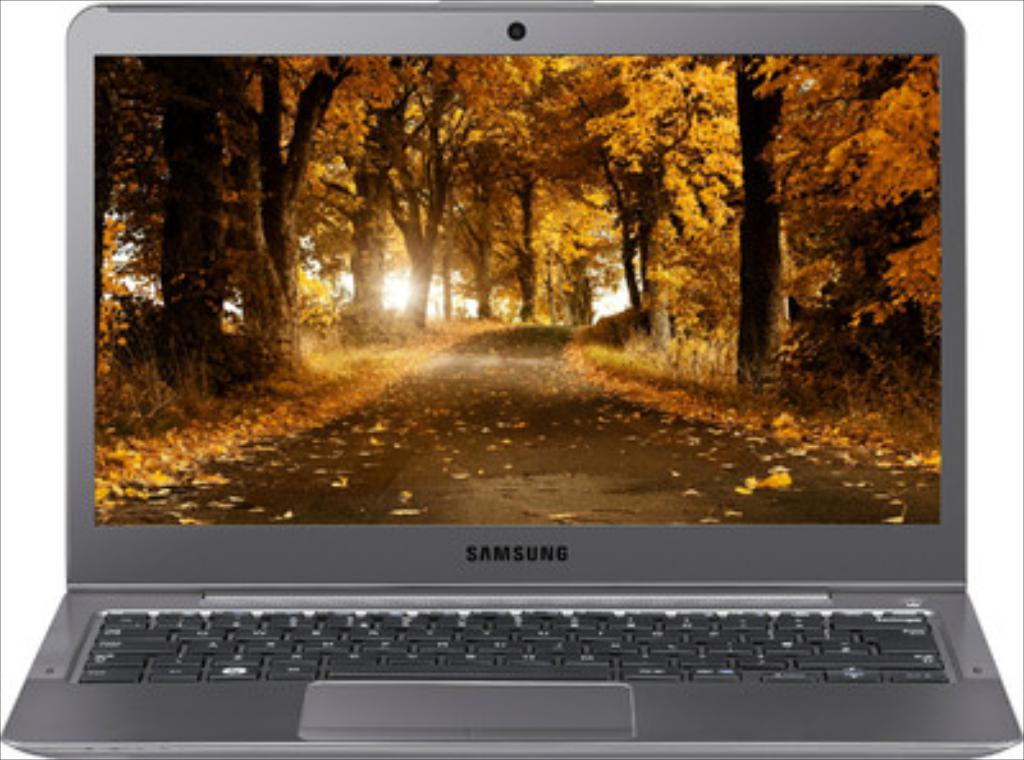<image>
Summarize the visual content of the image. A Samsung brand grey laptop computer on a white background and with a fall forest wallpaper. 